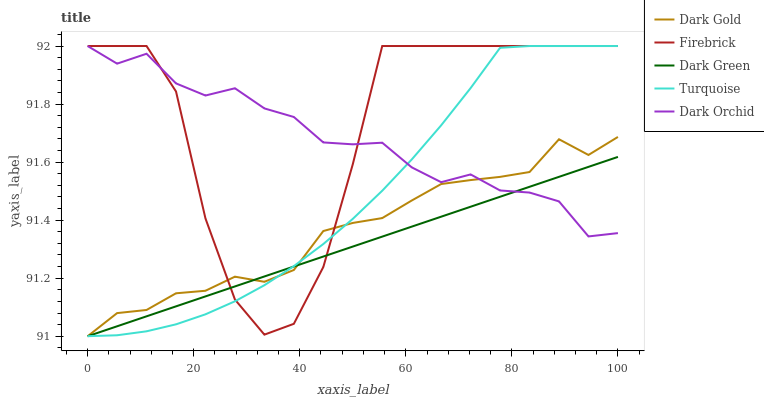Does Dark Green have the minimum area under the curve?
Answer yes or no. Yes. Does Firebrick have the maximum area under the curve?
Answer yes or no. Yes. Does Turquoise have the minimum area under the curve?
Answer yes or no. No. Does Turquoise have the maximum area under the curve?
Answer yes or no. No. Is Dark Green the smoothest?
Answer yes or no. Yes. Is Firebrick the roughest?
Answer yes or no. Yes. Is Turquoise the smoothest?
Answer yes or no. No. Is Turquoise the roughest?
Answer yes or no. No. Does Dark Green have the lowest value?
Answer yes or no. Yes. Does Turquoise have the lowest value?
Answer yes or no. No. Does Dark Orchid have the highest value?
Answer yes or no. Yes. Does Dark Green have the highest value?
Answer yes or no. No. Does Dark Green intersect Firebrick?
Answer yes or no. Yes. Is Dark Green less than Firebrick?
Answer yes or no. No. Is Dark Green greater than Firebrick?
Answer yes or no. No. 